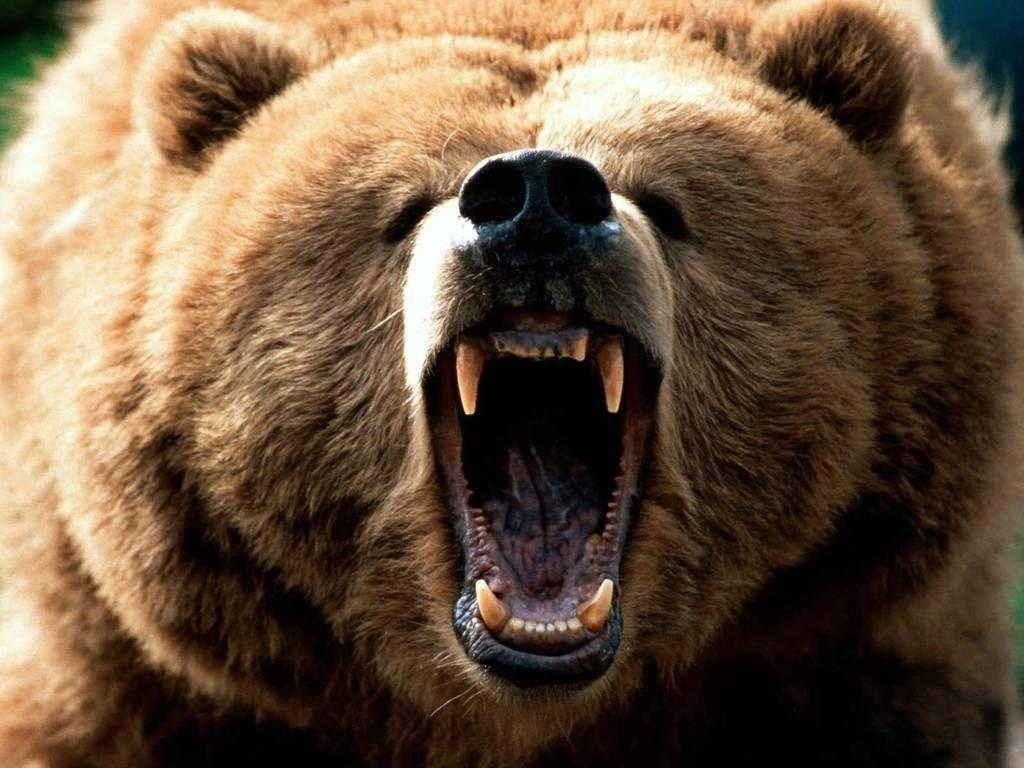What type of animal is in the picture? There is a brown bear in the picture. What part of the bear's body is visible in the picture? The jaws of the bear are visible in the picture. What type of flesh can be seen hanging from the bear's jaws in the image? There is no flesh visible in the image, and the bear's jaws are not shown to be holding anything. 